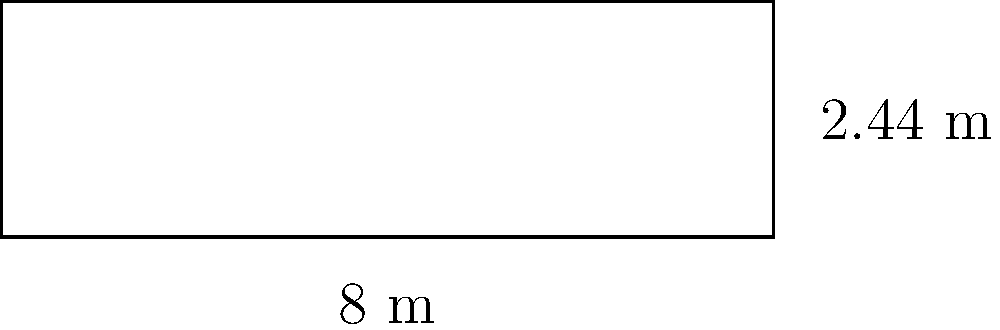足球球门是长方形的。如果球门宽度是 8 米，高度是 2.44 米，那么球门框的周长是多少米？

(The football goal is rectangular. If the goal width is 8 meters and the height is 2.44 meters, what is the perimeter of the goal frame in meters?) 让我们一步步计算：

1. 周长是长方形所有边的长度之和。

2. 长方形有四条边：两条长边和两条短边。

3. 长边（宽度）= 8 米
   短边（高度）= 2.44 米

4. 周长的计算公式是：
   $周长 = 2 \times 宽度 + 2 \times 高度$

5. 代入数值：
   $周长 = 2 \times 8 + 2 \times 2.44$
   $= 16 + 4.88$
   $= 20.88$ 米

所以，足球球门框的周长是 20.88 米。

(Let's calculate step by step:

1. The perimeter is the sum of all sides of the rectangle.

2. A rectangle has four sides: two long sides and two short sides.

3. Long side (width) = 8 meters
   Short side (height) = 2.44 meters

4. The formula for perimeter is:
   $Perimeter = 2 \times width + 2 \times height$

5. Substituting the values:
   $Perimeter = 2 \times 8 + 2 \times 2.44$
   $= 16 + 4.88$
   $= 20.88$ meters

So, the perimeter of the football goal frame is 20.88 meters.)
Answer: 20.88 米 (20.88 meters) 